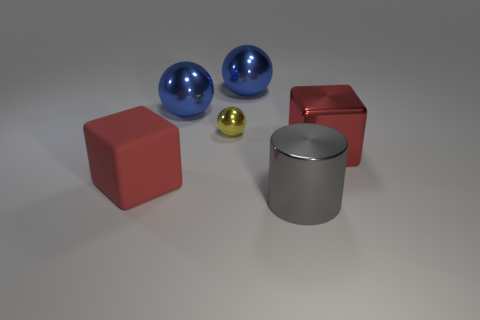Subtract all tiny metallic balls. How many balls are left? 2 Subtract 1 balls. How many balls are left? 2 Add 2 metallic things. How many objects exist? 8 Subtract all cubes. How many objects are left? 4 Add 5 gray metal spheres. How many gray metal spheres exist? 5 Subtract 0 blue cylinders. How many objects are left? 6 Subtract all large metal cubes. Subtract all large objects. How many objects are left? 0 Add 1 things. How many things are left? 7 